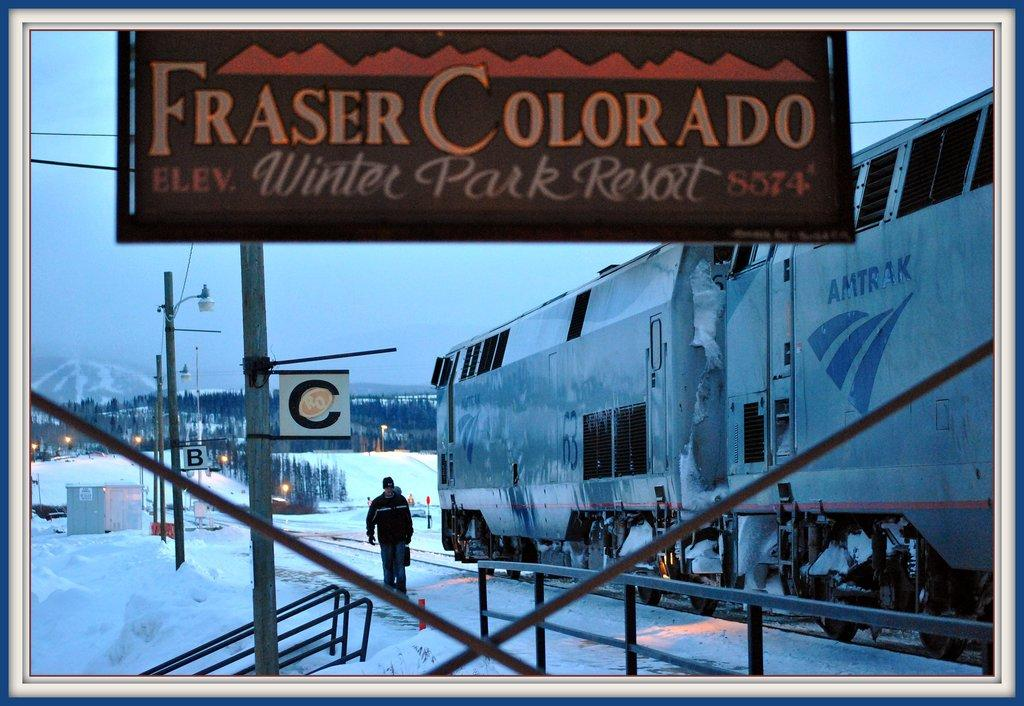<image>
Present a compact description of the photo's key features. A sign tells us that the elevation at the Winter Park Resort in Fraser Colorado is 8574. 